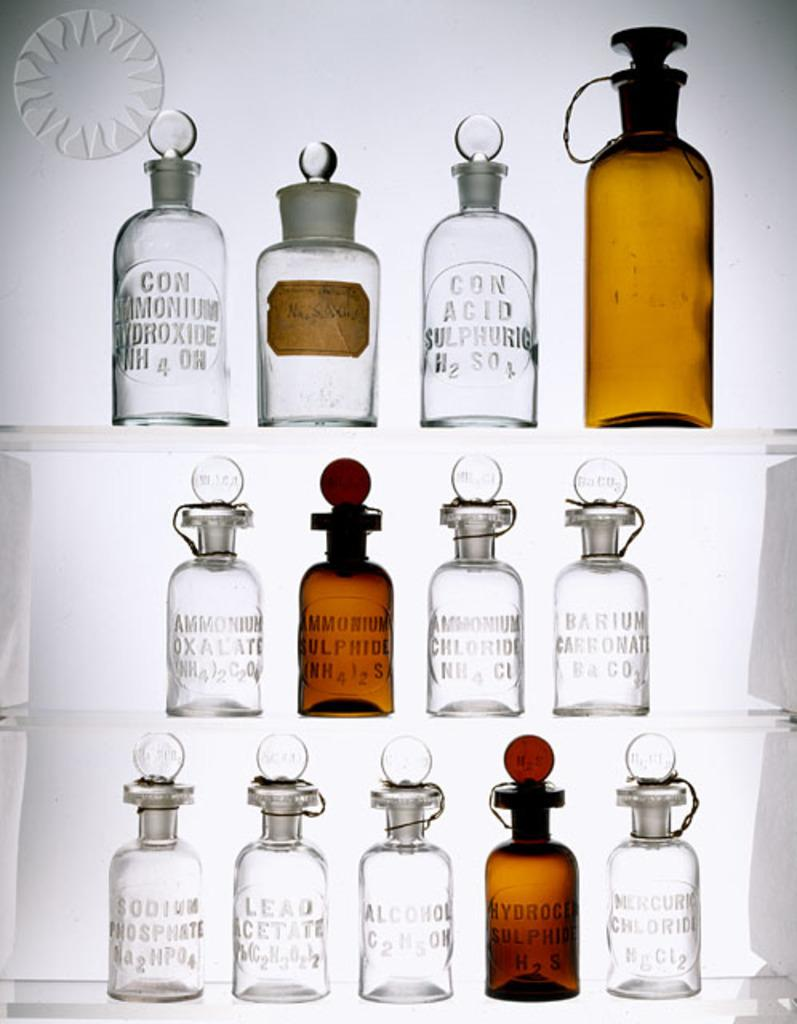What objects are present in the image? There are bottles in the image. What is inside the bottles? There is liquid in the bottles. What can be seen in the background of the image? There is a white wall in the background of the image. How many rabbits can be seen hopping through the hole in the image? There are no rabbits or holes present in the image. 